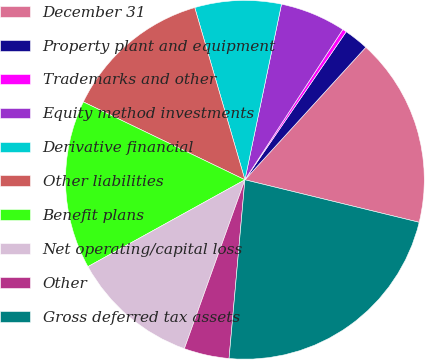<chart> <loc_0><loc_0><loc_500><loc_500><pie_chart><fcel>December 31<fcel>Property plant and equipment<fcel>Trademarks and other<fcel>Equity method investments<fcel>Derivative financial<fcel>Other liabilities<fcel>Benefit plans<fcel>Net operating/capital loss<fcel>Other<fcel>Gross deferred tax assets<nl><fcel>17.04%<fcel>2.22%<fcel>0.36%<fcel>5.92%<fcel>7.78%<fcel>13.34%<fcel>15.19%<fcel>11.48%<fcel>4.07%<fcel>22.6%<nl></chart> 